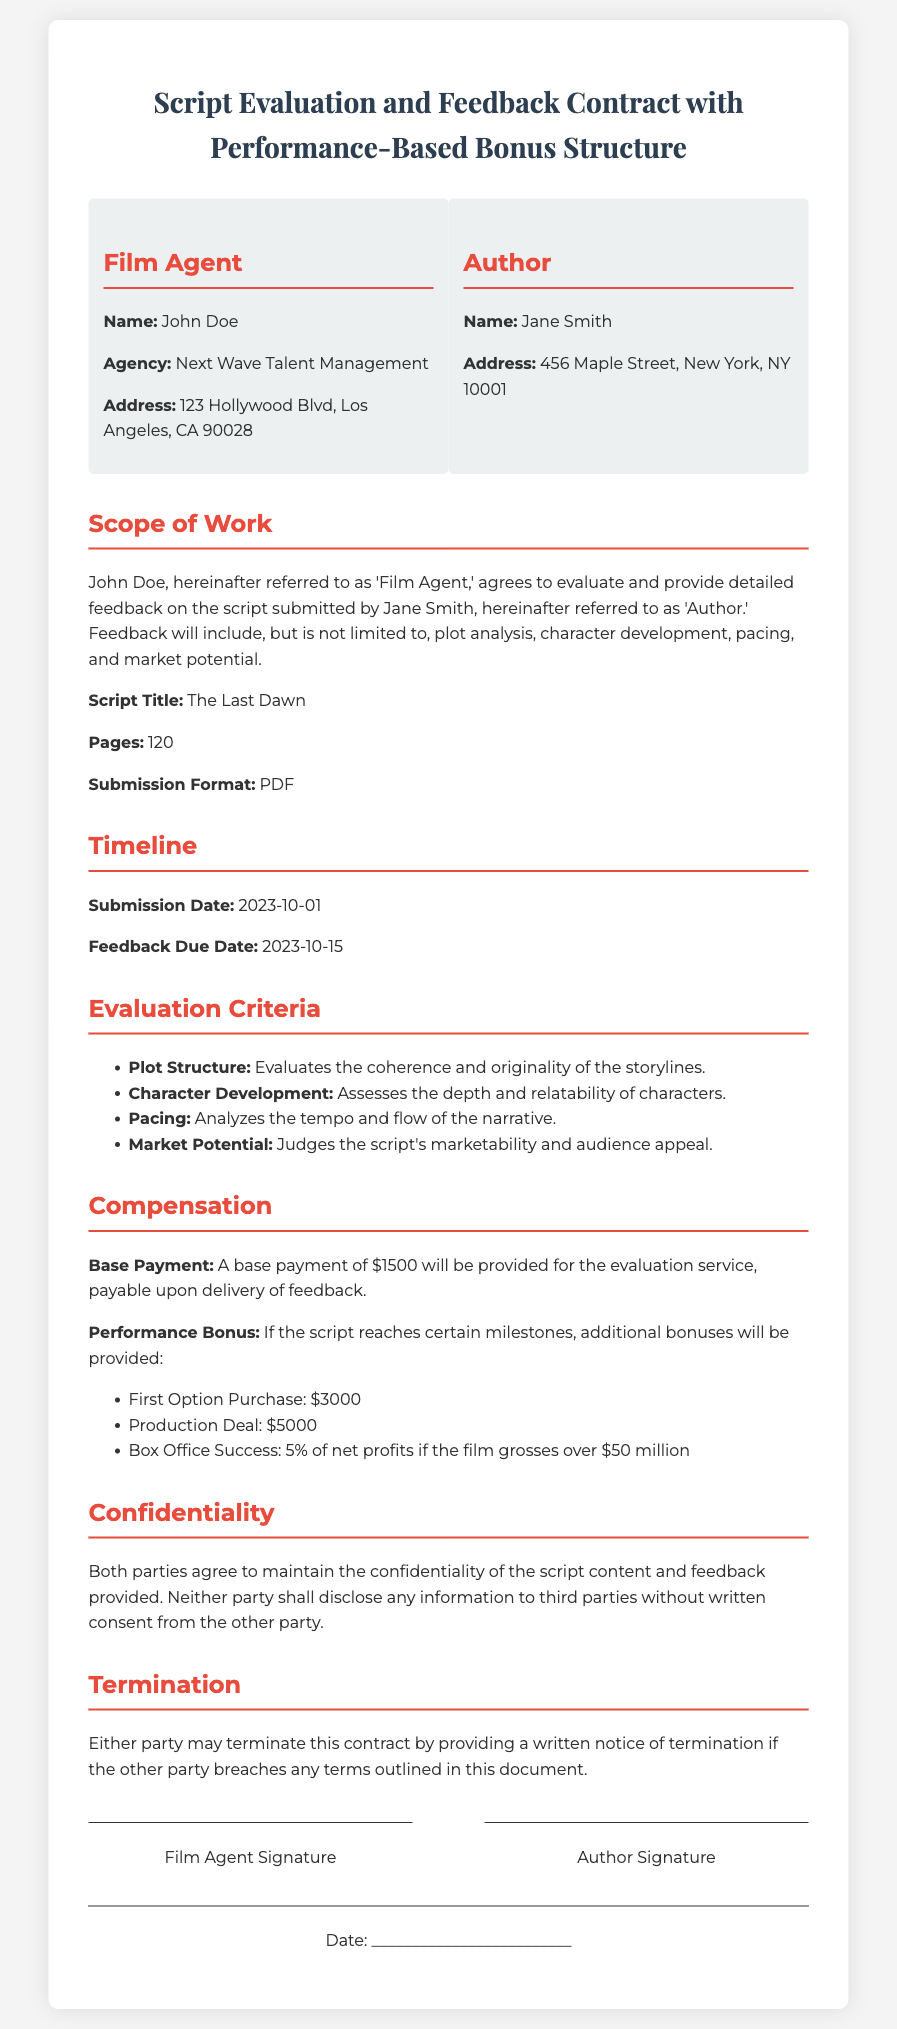What is the name of the Film Agent? The Film Agent is identified as John Doe in the document.
Answer: John Doe What is the base payment amount? The base payment for the evaluation service is mentioned as $1500.
Answer: $1500 What is the feedback due date? The feedback due date is explicitly stated as 2023-10-15 in the contract.
Answer: 2023-10-15 What are the evaluation criteria listed in the document? The document lists plot structure, character development, pacing, and market potential as evaluation criteria.
Answer: Plot Structure, Character Development, Pacing, Market Potential What is the performance bonus for box office success? The contract notes that 5% of net profits will be given if the film grosses over $50 million.
Answer: 5% of net profits What is the confidentiality clause about? The clause emphasizes maintaining confidentiality regarding the script content and feedback provided to prevent disclosure to third parties.
Answer: Maintain confidentiality What is the termination condition mentioned? The contract states that either party may terminate it upon written notice if any terms are breached.
Answer: Breach of terms What is the title of the script being evaluated? The title of the script submitted is clearly stated as The Last Dawn.
Answer: The Last Dawn What are the parties involved in the contract? The two parties to the contract are John Doe (Film Agent) and Jane Smith (Author).
Answer: John Doe, Jane Smith 